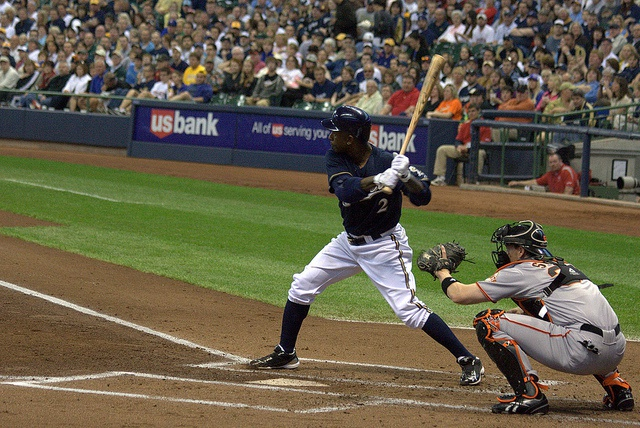Describe the objects in this image and their specific colors. I can see people in maroon, black, darkgray, gray, and darkgreen tones, people in maroon, black, lavender, gray, and darkgray tones, people in maroon, gray, black, and olive tones, people in maroon, gray, and black tones, and baseball bat in maroon, tan, olive, and gray tones in this image. 